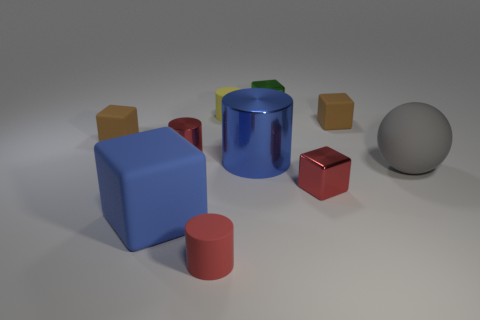What is the size of the blue block that is made of the same material as the large sphere?
Offer a terse response. Large. There is a large matte object right of the small shiny block behind the large sphere; is there a green object that is in front of it?
Ensure brevity in your answer.  No. Is the size of the brown block that is on the left side of the green shiny object the same as the big shiny cylinder?
Make the answer very short. No. What number of shiny cylinders are the same size as the yellow thing?
Make the answer very short. 1. What size is the rubber block that is the same color as the big cylinder?
Your answer should be compact. Large. Is the color of the large sphere the same as the large metal cylinder?
Make the answer very short. No. What shape is the large metallic thing?
Your response must be concise. Cylinder. Is there a shiny cylinder of the same color as the rubber ball?
Provide a short and direct response. No. Is the number of gray matte objects that are in front of the blue rubber object greater than the number of large shiny cylinders?
Ensure brevity in your answer.  No. Does the gray rubber thing have the same shape as the big matte thing that is on the left side of the red rubber object?
Your answer should be very brief. No. 